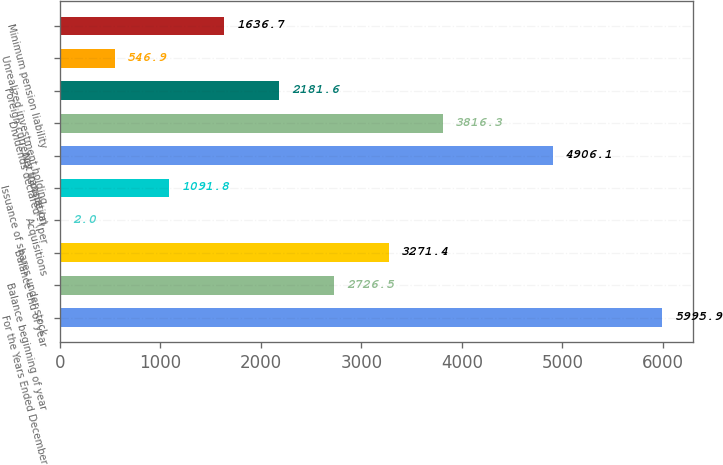Convert chart to OTSL. <chart><loc_0><loc_0><loc_500><loc_500><bar_chart><fcel>For the Years Ended December<fcel>Balance beginning of year<fcel>Balance end of year<fcel>Acquisitions<fcel>Issuance of shares under stock<fcel>Net income (a)<fcel>Dividends declared - (per<fcel>Foreign currency translation<fcel>Unrealized investment holding<fcel>Minimum pension liability<nl><fcel>5995.9<fcel>2726.5<fcel>3271.4<fcel>2<fcel>1091.8<fcel>4906.1<fcel>3816.3<fcel>2181.6<fcel>546.9<fcel>1636.7<nl></chart> 